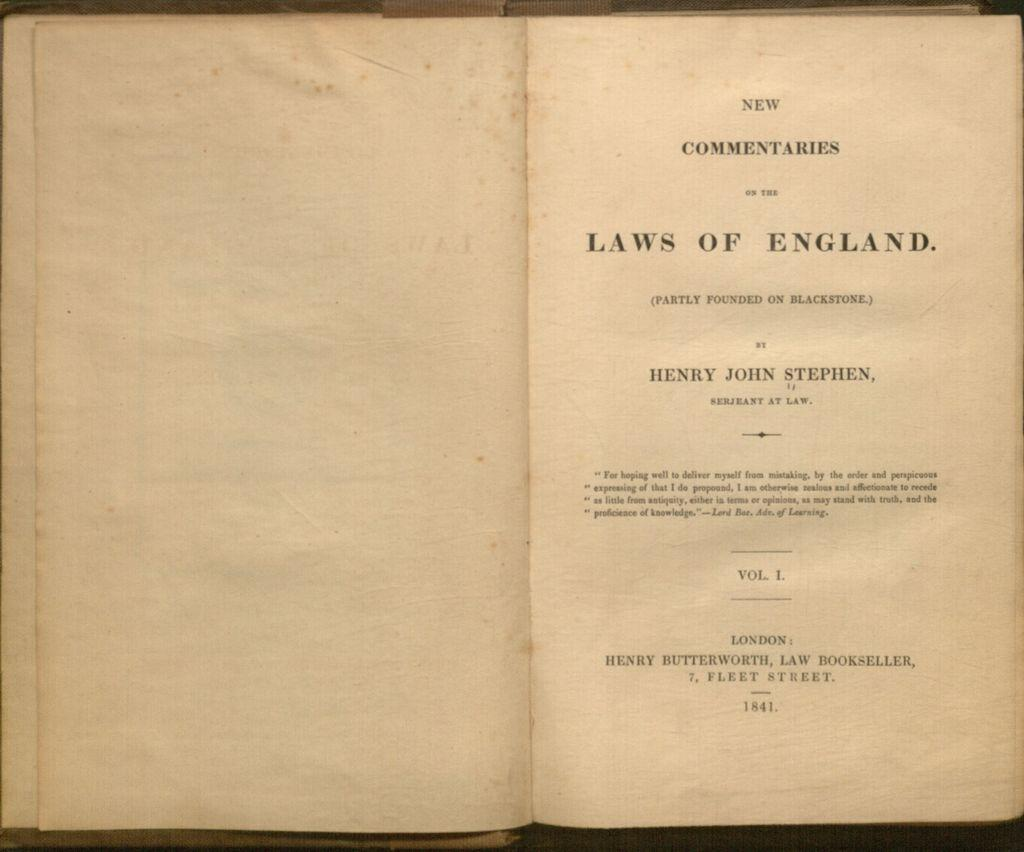<image>
Render a clear and concise summary of the photo. A book is opened and reveals an author name of Henry John Stephen. 